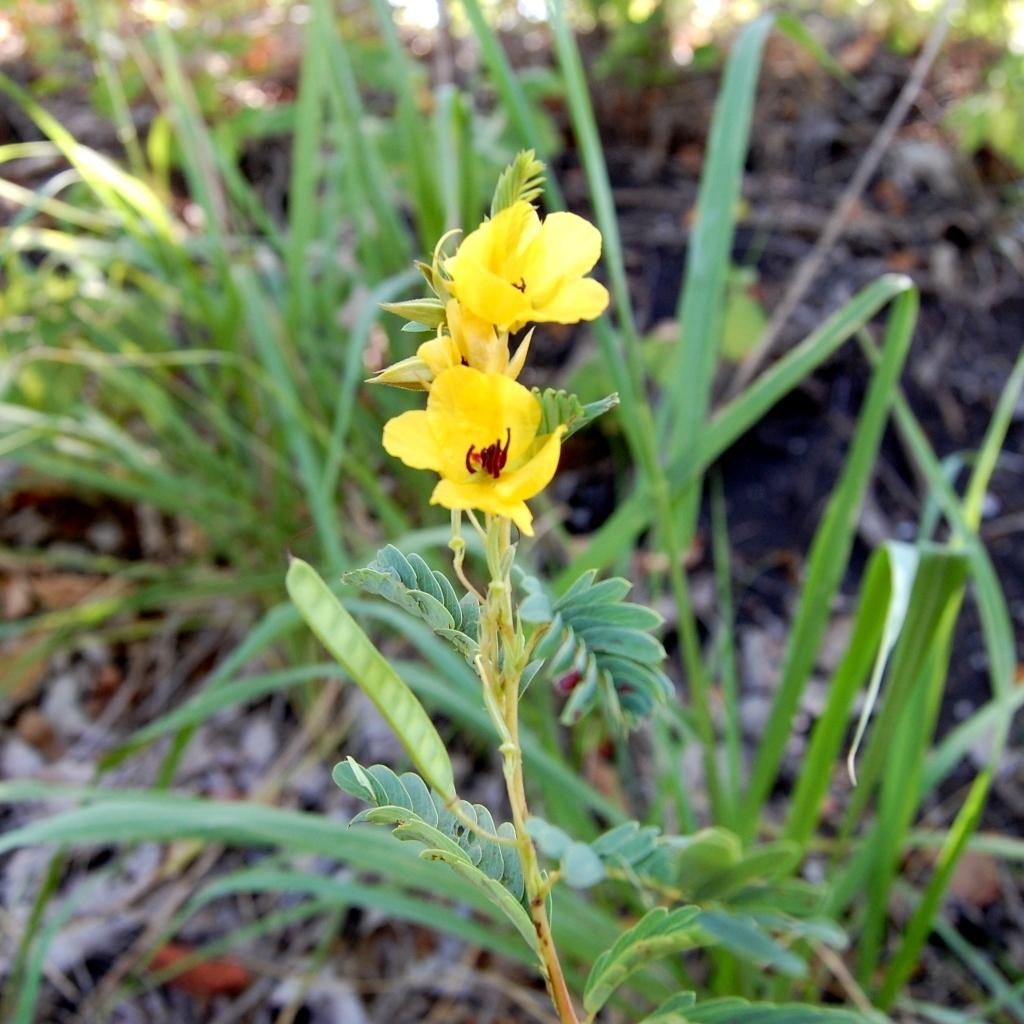What type of flowers can be seen on the plant in the image? There are yellow color flowers on a plant in the image. What type of vegetation is visible in the image besides the flowers? There is grass visible in the image. Can you describe the background of the image? The background of the image is blurred. What type of country is visible in the background of the image? There is no country visible in the background of the image; the background is blurred. 